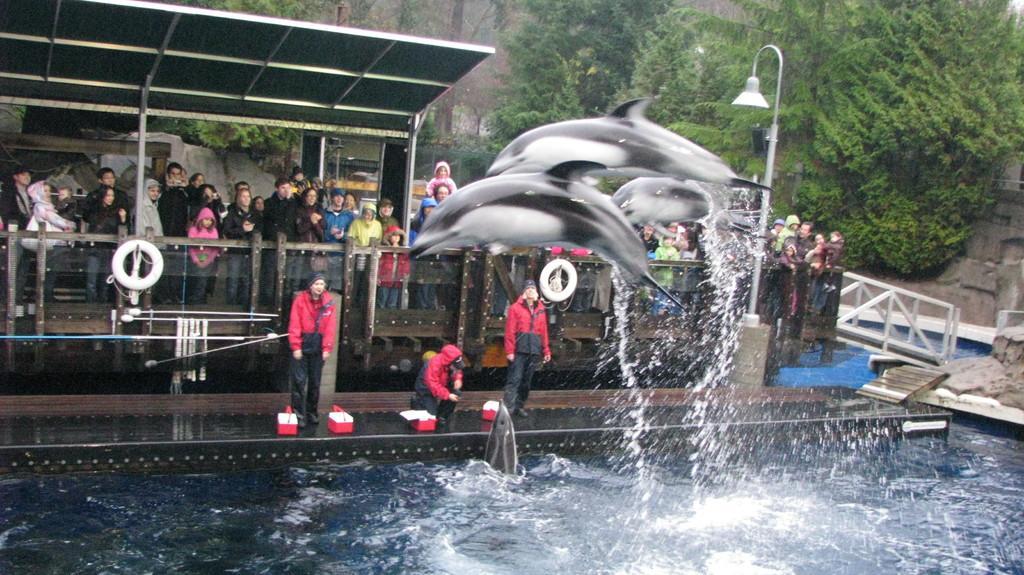Please provide a concise description of this image. In the picture we can see the water surface from it, we can see two dolphins are jumping and behind it, we can see three people are standing on the path and behind them, we can see a railing and behind the railing we can see some people are standing under the shed and in the background we can see the trees. 